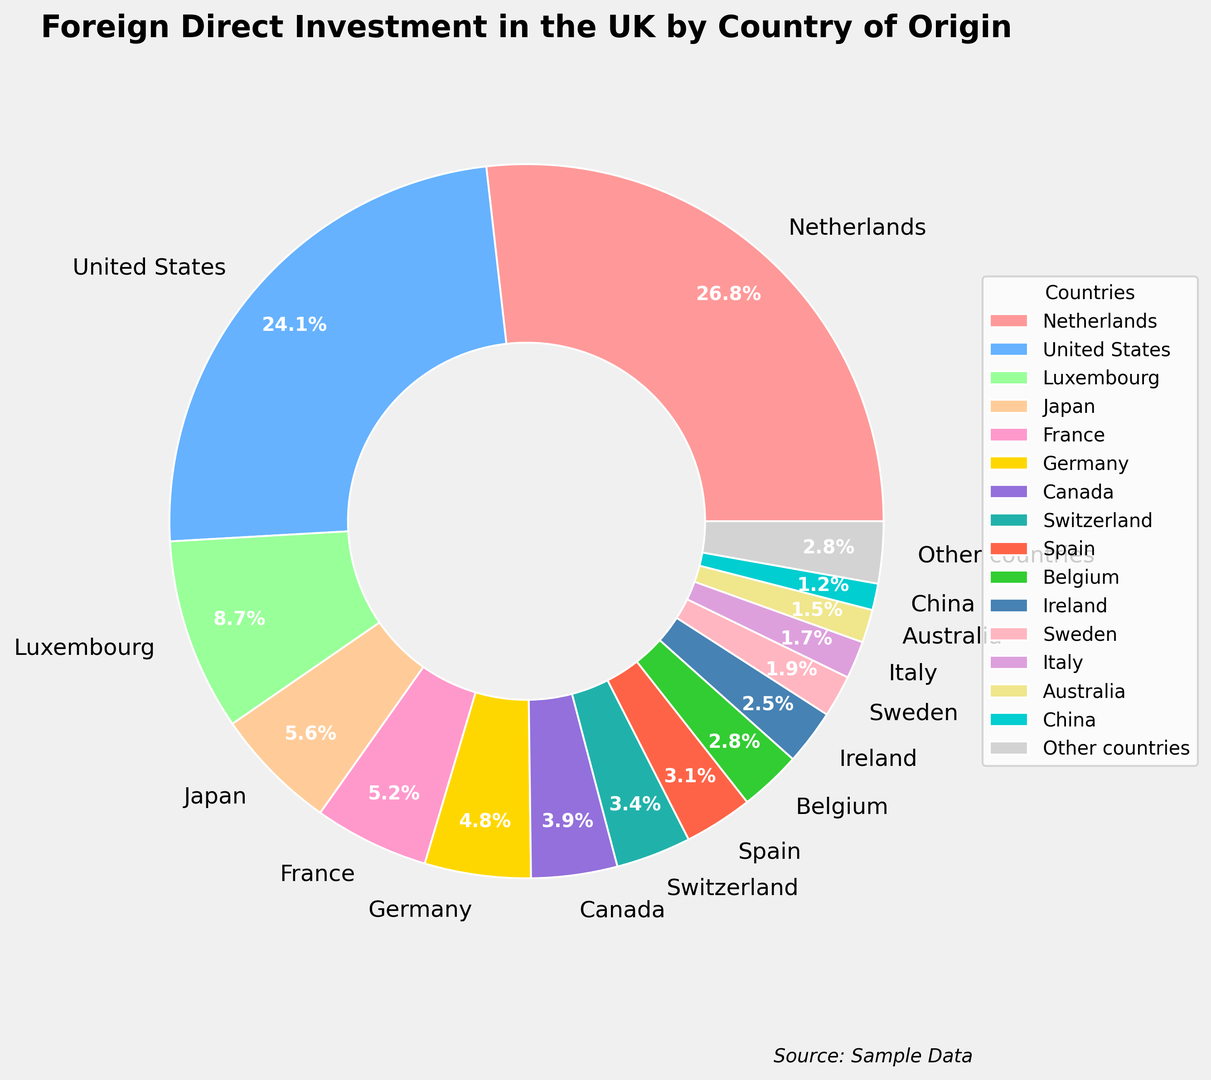Which country has the largest percentage of foreign direct investment in the UK? The largest percentage can be seen on the biggest wedge of the pie chart, which is for the Netherlands.
Answer: Netherlands What is the combined percentage of foreign direct investments from the United States and Luxembourg? Sum the percentages of the United States and Luxembourg: 24.1% + 8.7% = 32.8%.
Answer: 32.8% Which countries have equal percentages of foreign direct investment in the UK? By examining the wedges of the pie chart, we can see that Belgium and other countries both have a percentage of 2.8%.
Answer: Belgium, Other countries Is the percentage of foreign direct investment from Japan greater than that from Canada? Compare the wedges labeled Japan (5.6%) and Canada (3.9%) in the pie chart: 5.6% is indeed greater than 3.9%.
Answer: Yes What is the difference in the percentage of foreign direct investments between France and Germany? Subtract the percentage of Germany from France: 5.2% - 4.8% = 0.4%.
Answer: 0.4% What is the total percentage of foreign direct investments from countries that individually contribute less than 5%? Add the percentages of Luxembourg, Japan, France, Germany, Canada, Switzerland, Spain, Belgium, Ireland, Sweden, Italy, Australia, China, and other countries, all of which are less than 5% individually: 8.7% + 5.6% + 5.2% + 4.8% + 3.9% + 3.4% + 3.1% + 2.8% + 2.5% + 1.9% + 1.7% + 1.5% + 1.2% + 2.8% = 49.1%.
Answer: 49.1% What is the difference between the combined percentage of investments from the top three contributing countries and the combined percentage of the next three countries? First, sum the percentages of the top three countries (Netherlands, United States, Luxembourg): 26.8% + 24.1% + 8.7% = 59.6%. Next, sum the percentages of the next three countries (Japan, France, Germany): 5.6% + 5.2% + 4.8% = 15.6%. Finally, subtract the second sum from the first: 59.6% - 15.6% = 44%.
Answer: 44% What color is used to represent China's contribution to foreign direct investment in the UK? By inspecting the pie chart, the color representing China’s 1.2% contribution is a shade of light blue.
Answer: Light blue 